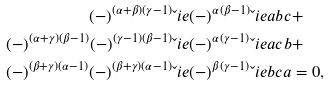Convert formula to latex. <formula><loc_0><loc_0><loc_500><loc_500>( - ) ^ { ( \alpha + \beta ) ( \gamma - 1 ) } & \L i e { ( - ) ^ { \alpha ( \beta - 1 ) } \L i e { a } { b } } { c } + \\ ( - ) ^ { ( \alpha + \gamma ) ( \beta - 1 ) } ( - ) ^ { ( \gamma - 1 ) ( \beta - 1 ) } & \L i e { ( - ) ^ { \alpha ( \gamma - 1 ) } \L i e { a } { c } } { b } + \\ ( - ) ^ { ( \beta + \gamma ) ( \alpha - 1 ) } ( - ) ^ { ( \beta + \gamma ) ( \alpha - 1 ) } & \L i e { ( - ) ^ { \beta ( \gamma - 1 ) } \L i e { b } { c } } { a } = 0 ,</formula> 